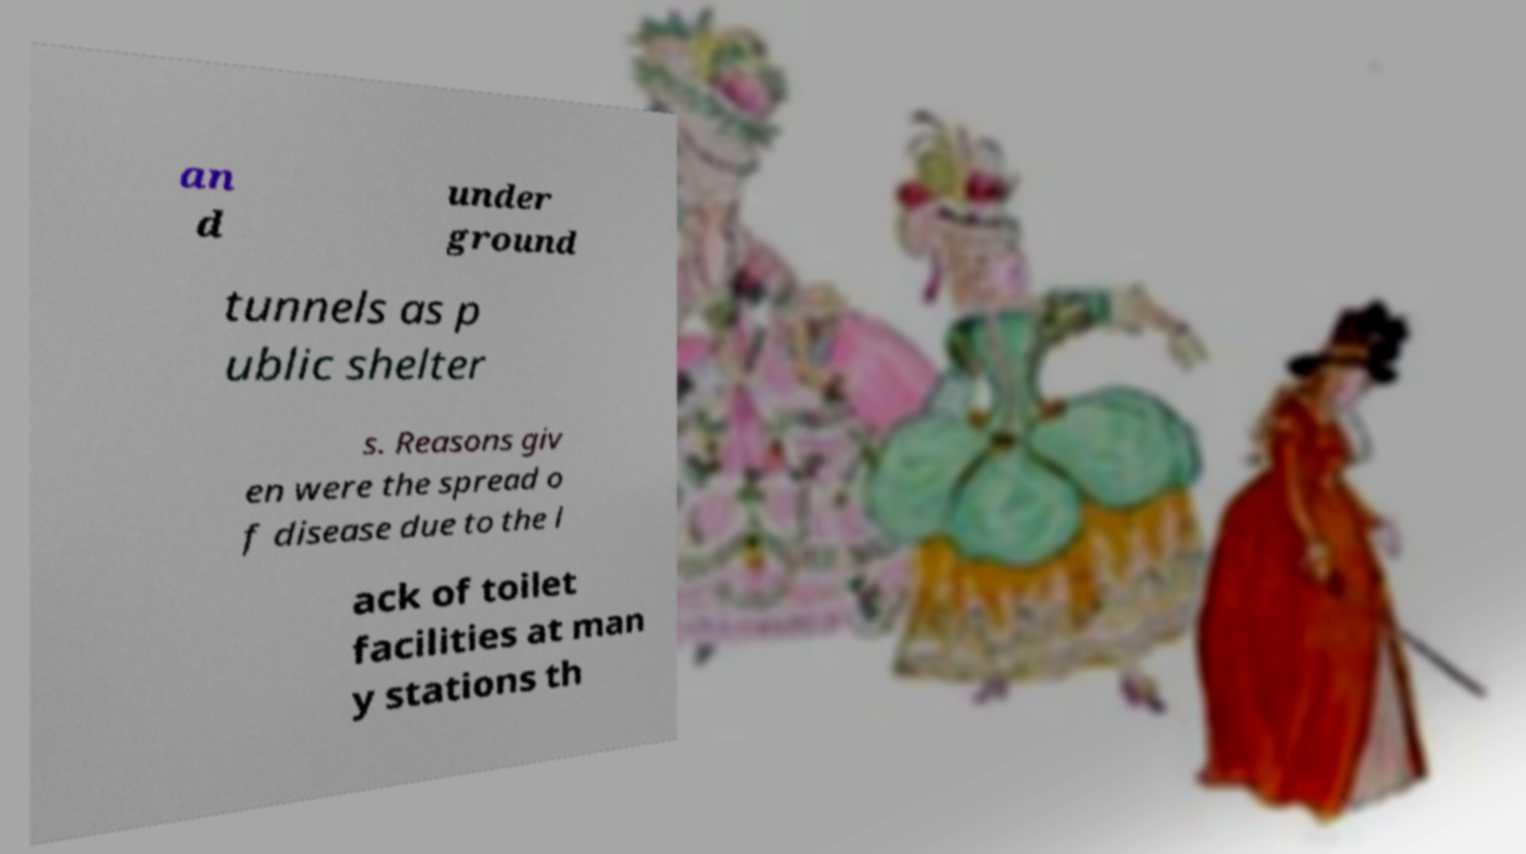I need the written content from this picture converted into text. Can you do that? an d under ground tunnels as p ublic shelter s. Reasons giv en were the spread o f disease due to the l ack of toilet facilities at man y stations th 